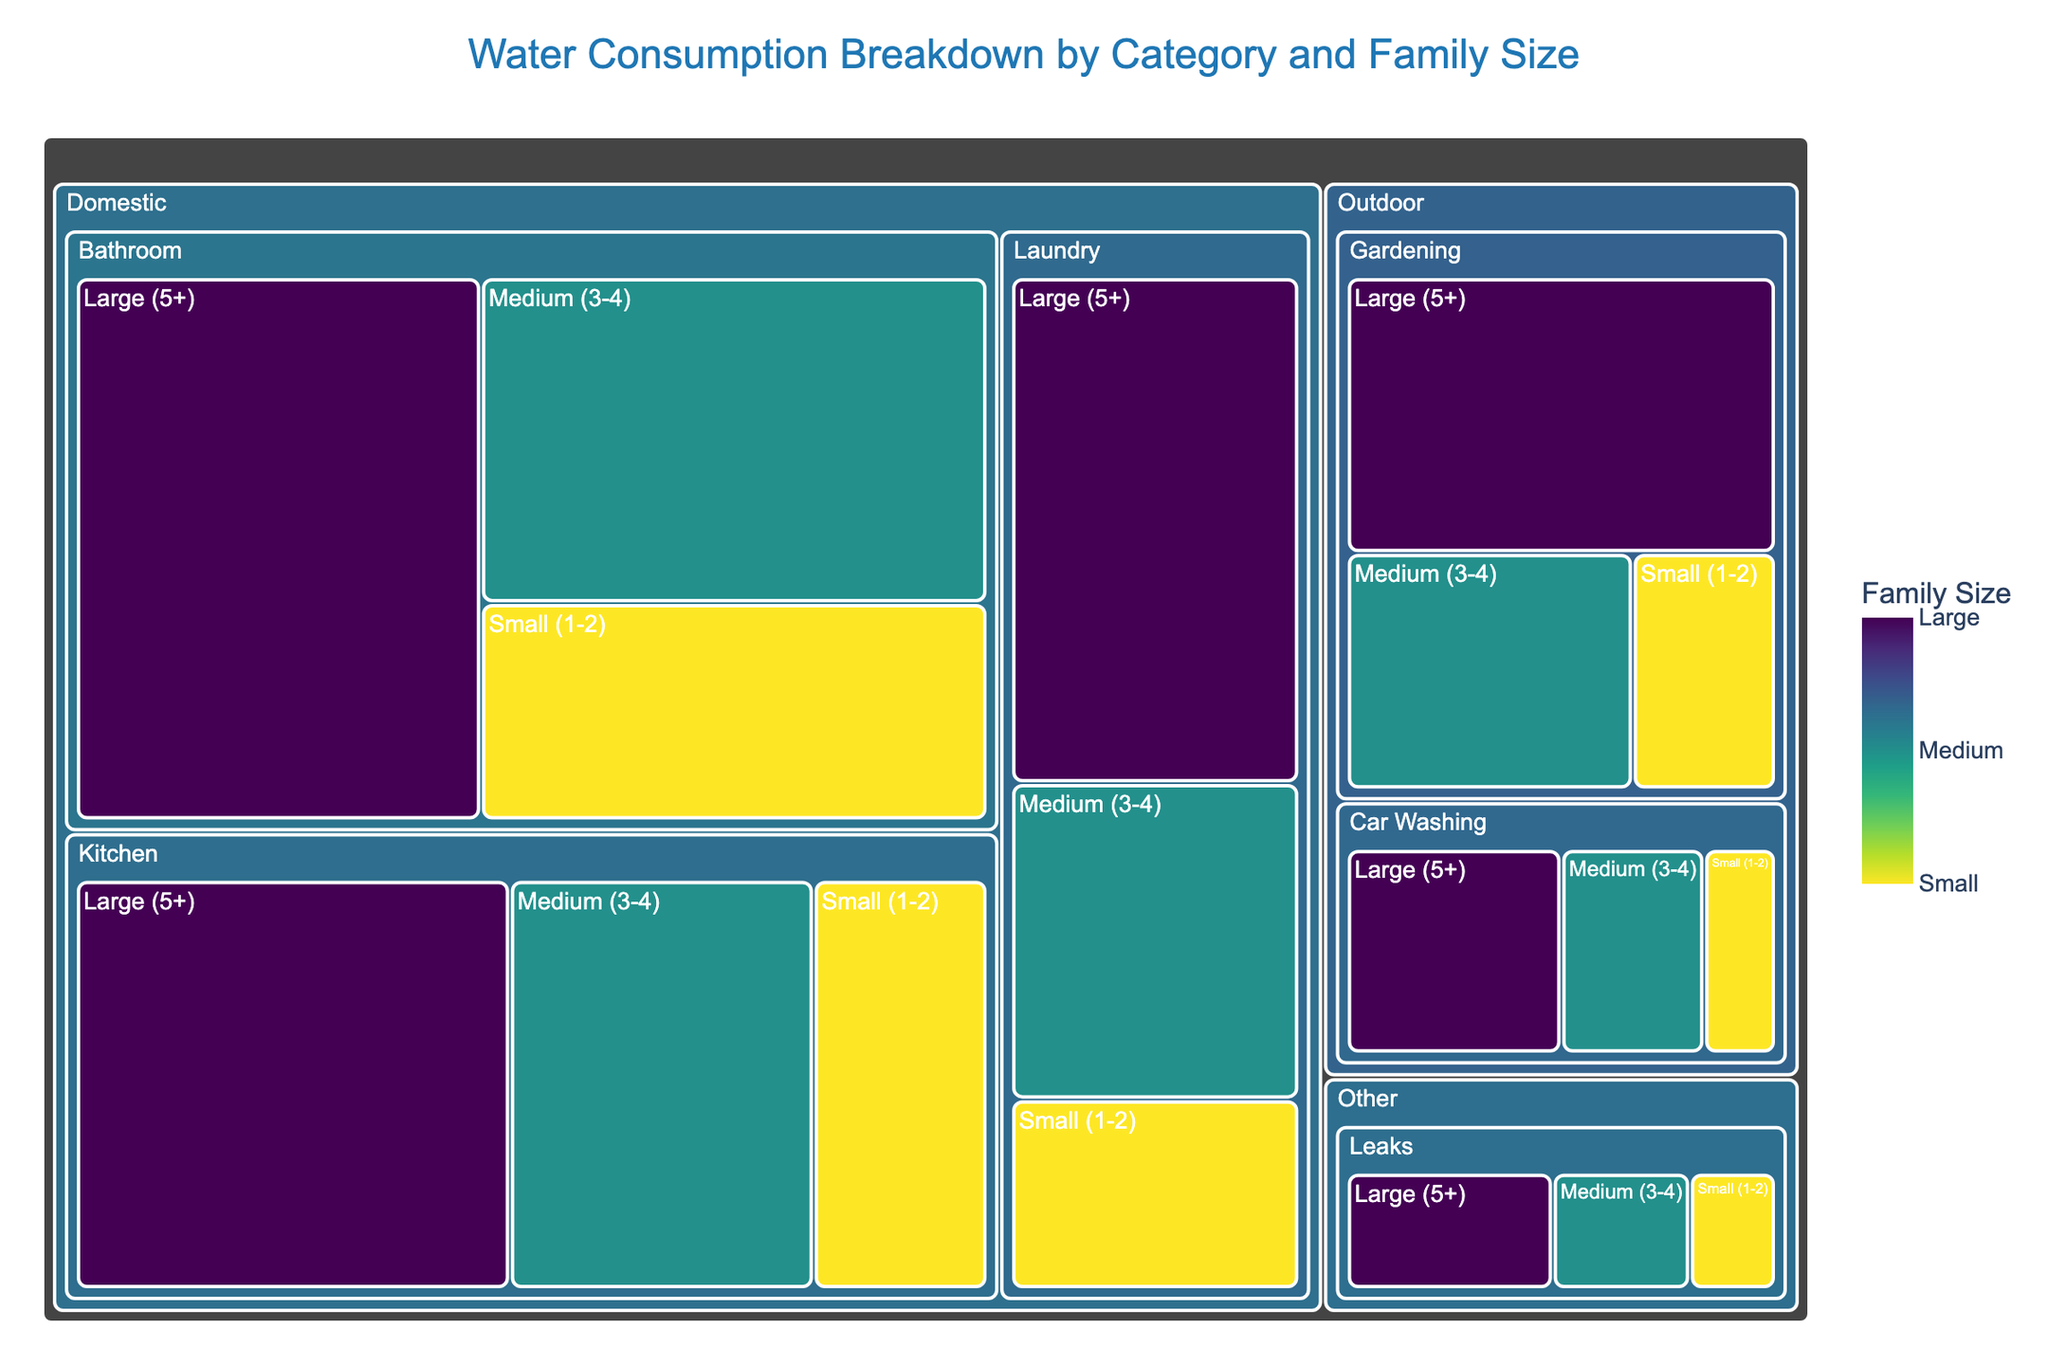What is the title of the Treemap? The title is usually found at the top of the Treemap, which describes the overall topic of the data shown.
Answer: Water Consumption Breakdown by Category and Family Size How can you identify the family size within each category and subcategory? Each rectangle within the main categories and subcategories is colored according to the family size, with a corresponding color scale on the side labeled "Family Size".
Answer: By color and label Which subcategory under the 'Outdoor' category has the highest water consumption for a Large family size? To find this, locate the 'Outdoor' category, then check the 'Gardening' and 'Car Washing' subcategories for the consumption values for 'Large (5+)' family size. 'Gardening' shows 35 units, and 'Car Washing' shows 15 units.
Answer: Gardening What is the total water consumption for 'Laundry' across all family sizes? Add the consumption values for 'Laundry' from 'Small (1-2)', 'Medium (3-4)', and 'Large (5+)' groups: 15 + 25 + 40 = 80 units.
Answer: 80 units Compare the water consumption of 'Kitchen' for Medium and Large family sizes. Which one is higher and by how much? 'Kitchen' consumption for Medium (3-4) is 35 units and for Large (5+) is 50 units. The difference is 50 - 35 = 15 units.
Answer: Large, by 15 units Which category has the smallest contribution to overall water consumption? Identify the category with the sum of its subcategories having the smallest consumption. 'Other' has 5 + 8 + 12 = 25 units, which is less than 'Domestic' and 'Outdoor'.
Answer: Other How does water consumption for 'Gardening' in 'Large' families compare to 'Bathroom' in 'Medium' families? Compare the given values: 'Gardening' for 'Large (5+)' is 35 units, and 'Bathroom' for 'Medium (3-4)' is 45 units.
Answer: Bathroom for Medium is higher What is the combined water consumption for 'Small (1-2)' families in the 'Domestic' category? Sum 'Small (1-2)' consumption in 'Bathroom', 'Kitchen', and 'Laundry': 30 + 20 + 15 = 65 units.
Answer: 65 units How does 'Laundry' consumption for 'Large (5+)' families compare to total 'Outdoor' consumption for 'Medium (3-4)' families? 'Laundry' for 'Large (5+)' is 40 units, while 'Outdoor' for 'Medium (3-4)' is 20 + 10 = 30 units.
Answer: Laundry for Large is higher What is the average water consumption per category? Calculate the total for each category and average it by dividing by the number of subcategories. E.g., 'Domestic' total is 255 units (consumption of all subcategories), divided by 3 subcategories is 255/3 = 85 units per subcategory on average.
Answer: Domestic: 85 units, Outdoor: 20 units per subcategory (100/2), Other: 8.33 units (25/3) 